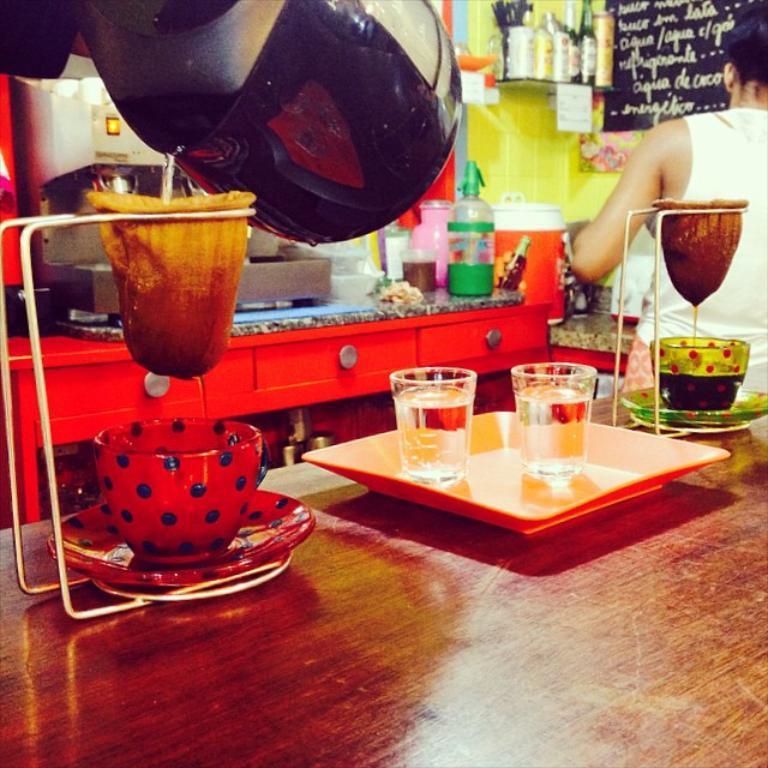Describe this image in one or two sentences. In this image I can see a person is standing. On the table there is a glasses in the tray. There is cup and a saucer. We can see a filter. At the back side there is a counter-top,on it there are bottles and a containers. There are bottles at the background. The wall is in green color. 